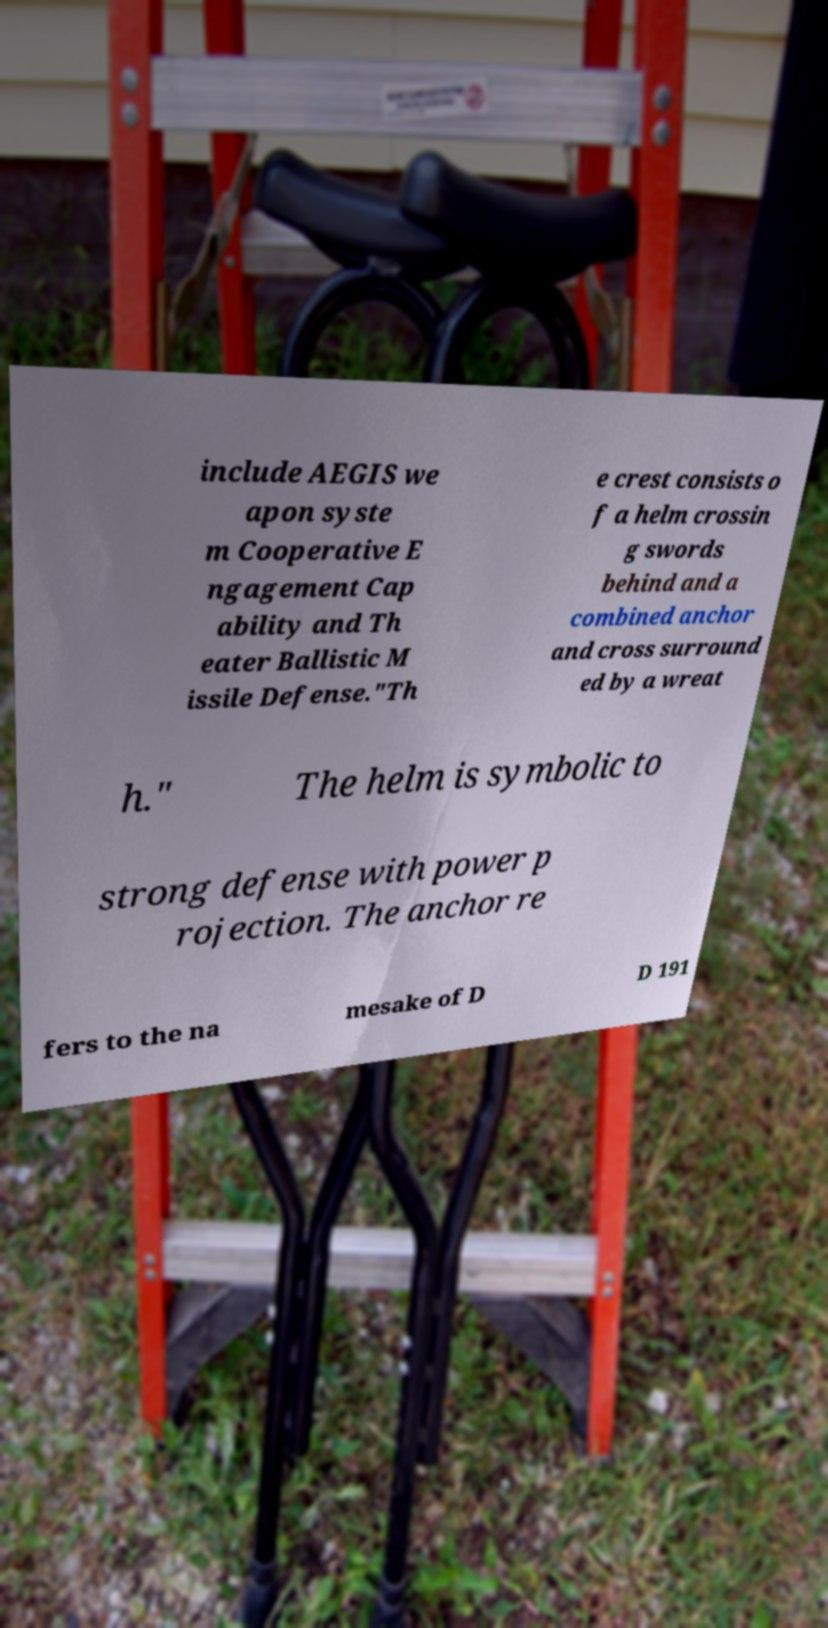Please identify and transcribe the text found in this image. include AEGIS we apon syste m Cooperative E ngagement Cap ability and Th eater Ballistic M issile Defense."Th e crest consists o f a helm crossin g swords behind and a combined anchor and cross surround ed by a wreat h." The helm is symbolic to strong defense with power p rojection. The anchor re fers to the na mesake of D D 191 